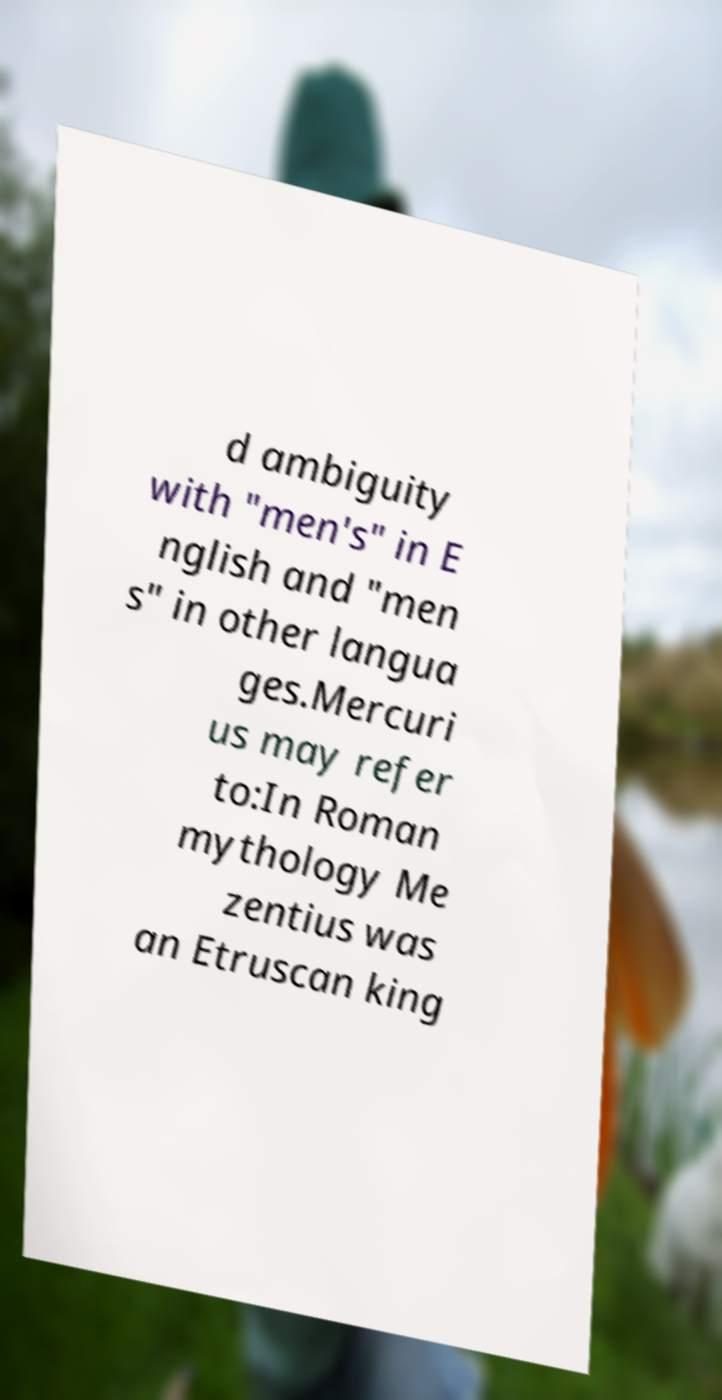Can you read and provide the text displayed in the image?This photo seems to have some interesting text. Can you extract and type it out for me? d ambiguity with "men's" in E nglish and "men s" in other langua ges.Mercuri us may refer to:In Roman mythology Me zentius was an Etruscan king 